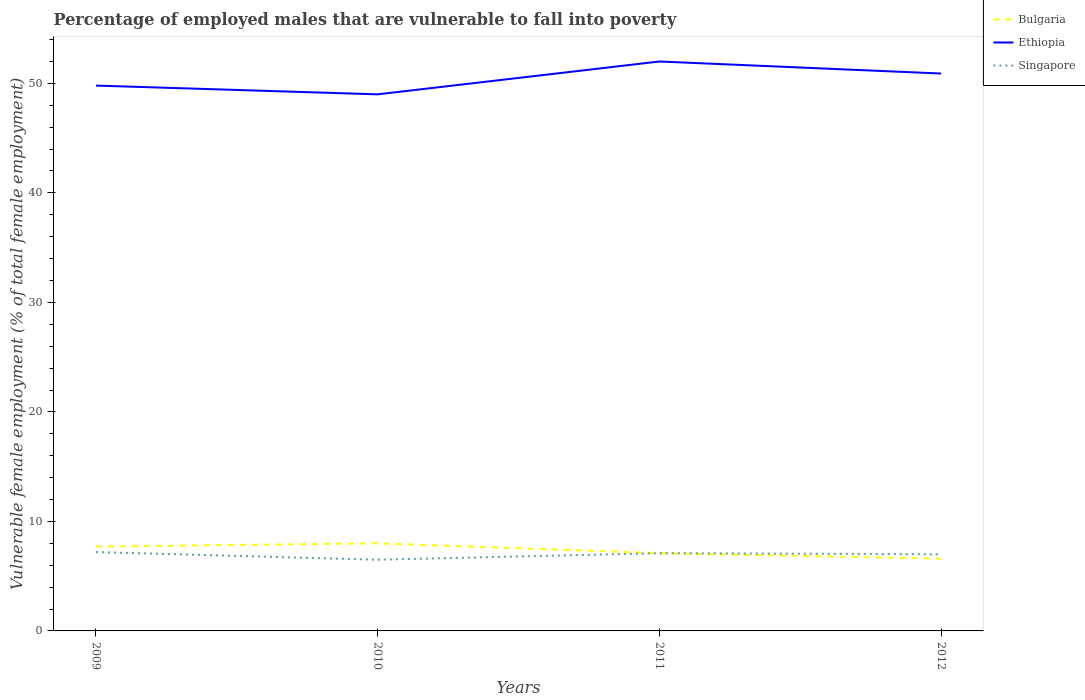How many different coloured lines are there?
Your response must be concise. 3. Does the line corresponding to Ethiopia intersect with the line corresponding to Singapore?
Offer a very short reply. No. Is the number of lines equal to the number of legend labels?
Your answer should be compact. Yes. Across all years, what is the maximum percentage of employed males who are vulnerable to fall into poverty in Singapore?
Provide a succinct answer. 6.5. In which year was the percentage of employed males who are vulnerable to fall into poverty in Singapore maximum?
Offer a terse response. 2010. What is the total percentage of employed males who are vulnerable to fall into poverty in Bulgaria in the graph?
Offer a terse response. 0.5. What is the difference between the highest and the second highest percentage of employed males who are vulnerable to fall into poverty in Bulgaria?
Provide a short and direct response. 1.4. What is the difference between the highest and the lowest percentage of employed males who are vulnerable to fall into poverty in Ethiopia?
Offer a terse response. 2. Are the values on the major ticks of Y-axis written in scientific E-notation?
Give a very brief answer. No. Does the graph contain any zero values?
Provide a succinct answer. No. What is the title of the graph?
Your answer should be compact. Percentage of employed males that are vulnerable to fall into poverty. What is the label or title of the Y-axis?
Provide a short and direct response. Vulnerable female employment (% of total female employment). What is the Vulnerable female employment (% of total female employment) in Bulgaria in 2009?
Ensure brevity in your answer.  7.7. What is the Vulnerable female employment (% of total female employment) of Ethiopia in 2009?
Provide a short and direct response. 49.8. What is the Vulnerable female employment (% of total female employment) of Singapore in 2009?
Provide a succinct answer. 7.2. What is the Vulnerable female employment (% of total female employment) in Bulgaria in 2010?
Give a very brief answer. 8. What is the Vulnerable female employment (% of total female employment) of Ethiopia in 2010?
Ensure brevity in your answer.  49. What is the Vulnerable female employment (% of total female employment) of Singapore in 2010?
Provide a succinct answer. 6.5. What is the Vulnerable female employment (% of total female employment) of Bulgaria in 2011?
Your answer should be very brief. 7.1. What is the Vulnerable female employment (% of total female employment) of Singapore in 2011?
Your response must be concise. 7.1. What is the Vulnerable female employment (% of total female employment) in Bulgaria in 2012?
Ensure brevity in your answer.  6.6. What is the Vulnerable female employment (% of total female employment) in Ethiopia in 2012?
Keep it short and to the point. 50.9. What is the Vulnerable female employment (% of total female employment) of Singapore in 2012?
Your answer should be compact. 7. Across all years, what is the maximum Vulnerable female employment (% of total female employment) of Ethiopia?
Keep it short and to the point. 52. Across all years, what is the maximum Vulnerable female employment (% of total female employment) in Singapore?
Provide a succinct answer. 7.2. Across all years, what is the minimum Vulnerable female employment (% of total female employment) in Bulgaria?
Offer a very short reply. 6.6. What is the total Vulnerable female employment (% of total female employment) of Bulgaria in the graph?
Offer a very short reply. 29.4. What is the total Vulnerable female employment (% of total female employment) in Ethiopia in the graph?
Your response must be concise. 201.7. What is the total Vulnerable female employment (% of total female employment) in Singapore in the graph?
Offer a terse response. 27.8. What is the difference between the Vulnerable female employment (% of total female employment) in Bulgaria in 2009 and that in 2010?
Your answer should be very brief. -0.3. What is the difference between the Vulnerable female employment (% of total female employment) in Bulgaria in 2009 and that in 2011?
Offer a very short reply. 0.6. What is the difference between the Vulnerable female employment (% of total female employment) in Ethiopia in 2009 and that in 2011?
Your answer should be very brief. -2.2. What is the difference between the Vulnerable female employment (% of total female employment) of Singapore in 2009 and that in 2011?
Offer a terse response. 0.1. What is the difference between the Vulnerable female employment (% of total female employment) of Bulgaria in 2009 and that in 2012?
Provide a succinct answer. 1.1. What is the difference between the Vulnerable female employment (% of total female employment) in Ethiopia in 2009 and that in 2012?
Provide a succinct answer. -1.1. What is the difference between the Vulnerable female employment (% of total female employment) of Singapore in 2009 and that in 2012?
Give a very brief answer. 0.2. What is the difference between the Vulnerable female employment (% of total female employment) of Singapore in 2010 and that in 2011?
Provide a short and direct response. -0.6. What is the difference between the Vulnerable female employment (% of total female employment) in Bulgaria in 2011 and that in 2012?
Offer a terse response. 0.5. What is the difference between the Vulnerable female employment (% of total female employment) in Bulgaria in 2009 and the Vulnerable female employment (% of total female employment) in Ethiopia in 2010?
Ensure brevity in your answer.  -41.3. What is the difference between the Vulnerable female employment (% of total female employment) of Ethiopia in 2009 and the Vulnerable female employment (% of total female employment) of Singapore in 2010?
Your answer should be very brief. 43.3. What is the difference between the Vulnerable female employment (% of total female employment) in Bulgaria in 2009 and the Vulnerable female employment (% of total female employment) in Ethiopia in 2011?
Your answer should be compact. -44.3. What is the difference between the Vulnerable female employment (% of total female employment) in Bulgaria in 2009 and the Vulnerable female employment (% of total female employment) in Singapore in 2011?
Your answer should be very brief. 0.6. What is the difference between the Vulnerable female employment (% of total female employment) in Ethiopia in 2009 and the Vulnerable female employment (% of total female employment) in Singapore in 2011?
Your response must be concise. 42.7. What is the difference between the Vulnerable female employment (% of total female employment) in Bulgaria in 2009 and the Vulnerable female employment (% of total female employment) in Ethiopia in 2012?
Make the answer very short. -43.2. What is the difference between the Vulnerable female employment (% of total female employment) of Bulgaria in 2009 and the Vulnerable female employment (% of total female employment) of Singapore in 2012?
Make the answer very short. 0.7. What is the difference between the Vulnerable female employment (% of total female employment) in Ethiopia in 2009 and the Vulnerable female employment (% of total female employment) in Singapore in 2012?
Your answer should be compact. 42.8. What is the difference between the Vulnerable female employment (% of total female employment) in Bulgaria in 2010 and the Vulnerable female employment (% of total female employment) in Ethiopia in 2011?
Make the answer very short. -44. What is the difference between the Vulnerable female employment (% of total female employment) in Bulgaria in 2010 and the Vulnerable female employment (% of total female employment) in Singapore in 2011?
Make the answer very short. 0.9. What is the difference between the Vulnerable female employment (% of total female employment) of Ethiopia in 2010 and the Vulnerable female employment (% of total female employment) of Singapore in 2011?
Ensure brevity in your answer.  41.9. What is the difference between the Vulnerable female employment (% of total female employment) of Bulgaria in 2010 and the Vulnerable female employment (% of total female employment) of Ethiopia in 2012?
Make the answer very short. -42.9. What is the difference between the Vulnerable female employment (% of total female employment) of Bulgaria in 2010 and the Vulnerable female employment (% of total female employment) of Singapore in 2012?
Ensure brevity in your answer.  1. What is the difference between the Vulnerable female employment (% of total female employment) in Ethiopia in 2010 and the Vulnerable female employment (% of total female employment) in Singapore in 2012?
Your answer should be very brief. 42. What is the difference between the Vulnerable female employment (% of total female employment) of Bulgaria in 2011 and the Vulnerable female employment (% of total female employment) of Ethiopia in 2012?
Offer a terse response. -43.8. What is the difference between the Vulnerable female employment (% of total female employment) in Bulgaria in 2011 and the Vulnerable female employment (% of total female employment) in Singapore in 2012?
Offer a very short reply. 0.1. What is the difference between the Vulnerable female employment (% of total female employment) in Ethiopia in 2011 and the Vulnerable female employment (% of total female employment) in Singapore in 2012?
Your answer should be very brief. 45. What is the average Vulnerable female employment (% of total female employment) in Bulgaria per year?
Ensure brevity in your answer.  7.35. What is the average Vulnerable female employment (% of total female employment) in Ethiopia per year?
Your response must be concise. 50.42. What is the average Vulnerable female employment (% of total female employment) of Singapore per year?
Provide a succinct answer. 6.95. In the year 2009, what is the difference between the Vulnerable female employment (% of total female employment) of Bulgaria and Vulnerable female employment (% of total female employment) of Ethiopia?
Ensure brevity in your answer.  -42.1. In the year 2009, what is the difference between the Vulnerable female employment (% of total female employment) in Bulgaria and Vulnerable female employment (% of total female employment) in Singapore?
Your answer should be very brief. 0.5. In the year 2009, what is the difference between the Vulnerable female employment (% of total female employment) of Ethiopia and Vulnerable female employment (% of total female employment) of Singapore?
Give a very brief answer. 42.6. In the year 2010, what is the difference between the Vulnerable female employment (% of total female employment) in Bulgaria and Vulnerable female employment (% of total female employment) in Ethiopia?
Your answer should be very brief. -41. In the year 2010, what is the difference between the Vulnerable female employment (% of total female employment) in Bulgaria and Vulnerable female employment (% of total female employment) in Singapore?
Offer a very short reply. 1.5. In the year 2010, what is the difference between the Vulnerable female employment (% of total female employment) of Ethiopia and Vulnerable female employment (% of total female employment) of Singapore?
Give a very brief answer. 42.5. In the year 2011, what is the difference between the Vulnerable female employment (% of total female employment) of Bulgaria and Vulnerable female employment (% of total female employment) of Ethiopia?
Give a very brief answer. -44.9. In the year 2011, what is the difference between the Vulnerable female employment (% of total female employment) in Bulgaria and Vulnerable female employment (% of total female employment) in Singapore?
Give a very brief answer. 0. In the year 2011, what is the difference between the Vulnerable female employment (% of total female employment) in Ethiopia and Vulnerable female employment (% of total female employment) in Singapore?
Your answer should be compact. 44.9. In the year 2012, what is the difference between the Vulnerable female employment (% of total female employment) of Bulgaria and Vulnerable female employment (% of total female employment) of Ethiopia?
Provide a short and direct response. -44.3. In the year 2012, what is the difference between the Vulnerable female employment (% of total female employment) in Ethiopia and Vulnerable female employment (% of total female employment) in Singapore?
Your answer should be compact. 43.9. What is the ratio of the Vulnerable female employment (% of total female employment) in Bulgaria in 2009 to that in 2010?
Ensure brevity in your answer.  0.96. What is the ratio of the Vulnerable female employment (% of total female employment) of Ethiopia in 2009 to that in 2010?
Your answer should be very brief. 1.02. What is the ratio of the Vulnerable female employment (% of total female employment) of Singapore in 2009 to that in 2010?
Your response must be concise. 1.11. What is the ratio of the Vulnerable female employment (% of total female employment) in Bulgaria in 2009 to that in 2011?
Offer a very short reply. 1.08. What is the ratio of the Vulnerable female employment (% of total female employment) of Ethiopia in 2009 to that in 2011?
Give a very brief answer. 0.96. What is the ratio of the Vulnerable female employment (% of total female employment) of Singapore in 2009 to that in 2011?
Your answer should be compact. 1.01. What is the ratio of the Vulnerable female employment (% of total female employment) in Bulgaria in 2009 to that in 2012?
Your answer should be compact. 1.17. What is the ratio of the Vulnerable female employment (% of total female employment) of Ethiopia in 2009 to that in 2012?
Ensure brevity in your answer.  0.98. What is the ratio of the Vulnerable female employment (% of total female employment) in Singapore in 2009 to that in 2012?
Keep it short and to the point. 1.03. What is the ratio of the Vulnerable female employment (% of total female employment) in Bulgaria in 2010 to that in 2011?
Make the answer very short. 1.13. What is the ratio of the Vulnerable female employment (% of total female employment) in Ethiopia in 2010 to that in 2011?
Make the answer very short. 0.94. What is the ratio of the Vulnerable female employment (% of total female employment) in Singapore in 2010 to that in 2011?
Give a very brief answer. 0.92. What is the ratio of the Vulnerable female employment (% of total female employment) in Bulgaria in 2010 to that in 2012?
Provide a succinct answer. 1.21. What is the ratio of the Vulnerable female employment (% of total female employment) in Ethiopia in 2010 to that in 2012?
Provide a succinct answer. 0.96. What is the ratio of the Vulnerable female employment (% of total female employment) in Singapore in 2010 to that in 2012?
Your answer should be very brief. 0.93. What is the ratio of the Vulnerable female employment (% of total female employment) in Bulgaria in 2011 to that in 2012?
Your answer should be compact. 1.08. What is the ratio of the Vulnerable female employment (% of total female employment) in Ethiopia in 2011 to that in 2012?
Your response must be concise. 1.02. What is the ratio of the Vulnerable female employment (% of total female employment) of Singapore in 2011 to that in 2012?
Provide a succinct answer. 1.01. What is the difference between the highest and the second highest Vulnerable female employment (% of total female employment) in Ethiopia?
Provide a succinct answer. 1.1. What is the difference between the highest and the lowest Vulnerable female employment (% of total female employment) of Bulgaria?
Give a very brief answer. 1.4. What is the difference between the highest and the lowest Vulnerable female employment (% of total female employment) of Ethiopia?
Offer a terse response. 3. 